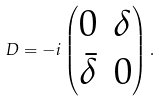Convert formula to latex. <formula><loc_0><loc_0><loc_500><loc_500>D = - i \begin{pmatrix} 0 & \delta \\ { \bar { \delta } } & 0 \end{pmatrix} .</formula> 